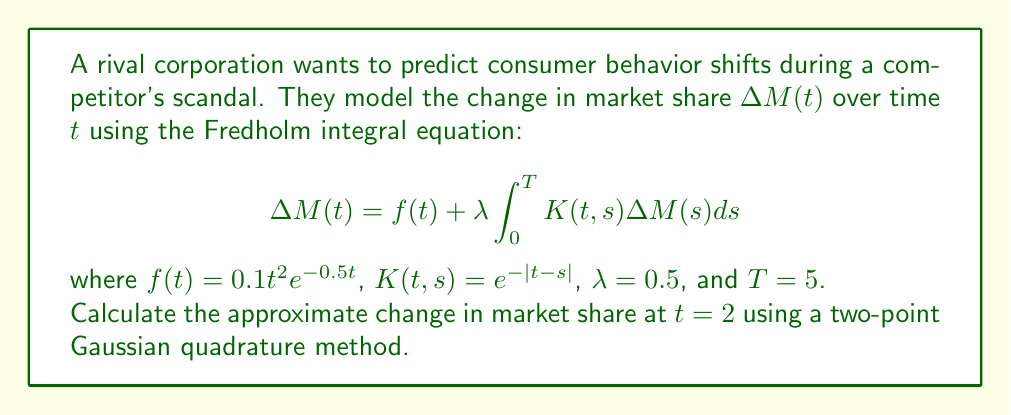Can you answer this question? To solve this problem, we'll follow these steps:

1) First, we need to discretize the integral equation using the Gaussian quadrature method. For a two-point method, we use the formula:

   $$\int_0^T g(x)dx \approx \frac{T}{2}[w_1g(x_1) + w_2g(x_2)]$$

   where $w_1 = w_2 = 1$, and $x_1 = \frac{T}{2}(1-\frac{1}{\sqrt{3}})$, $x_2 = \frac{T}{2}(1+\frac{1}{\sqrt{3}})$

2) Calculate $x_1$ and $x_2$:
   $x_1 = \frac{5}{2}(1-\frac{1}{\sqrt{3}}) \approx 1.0566$
   $x_2 = \frac{5}{2}(1+\frac{1}{\sqrt{3}}) \approx 3.9434$

3) Now, we can write our discretized equation:

   $$\Delta M(t) = f(t) + \lambda \frac{T}{2}[K(t,x_1)\Delta M(x_1) + K(t,x_2)\Delta M(x_2)]$$

4) We need to solve this equation for $t = 2$, $x_1$, and $x_2$. This gives us a system of three equations:

   $$\Delta M(2) = f(2) + \frac{5\lambda}{2}[K(2,x_1)\Delta M(x_1) + K(2,x_2)\Delta M(x_2)]$$
   $$\Delta M(x_1) = f(x_1) + \frac{5\lambda}{2}[K(x_1,x_1)\Delta M(x_1) + K(x_1,x_2)\Delta M(x_2)]$$
   $$\Delta M(x_2) = f(x_2) + \frac{5\lambda}{2}[K(x_2,x_1)\Delta M(x_1) + K(x_2,x_2)\Delta M(x_2)]$$

5) Calculate the values of $f(t)$ and $K(t,s)$:
   $f(2) = 0.1(2)^2e^{-0.5(2)} \approx 0.0811$
   $f(x_1) \approx 0.0304$
   $f(x_2) \approx 0.0399$
   $K(2,x_1) = e^{-|2-1.0566|} \approx 0.3937$
   $K(2,x_2) = e^{-|2-3.9434|} \approx 0.1451$
   $K(x_1,x_1) = 1$
   $K(x_1,x_2) = e^{-|1.0566-3.9434|} \approx 0.0578$
   $K(x_2,x_1) = e^{-|3.9434-1.0566|} \approx 0.0578$
   $K(x_2,x_2) = 1$

6) Substitute these values into our system of equations:

   $$\Delta M(2) = 0.0811 + 1.25[0.3937\Delta M(x_1) + 0.1451\Delta M(x_2)]$$
   $$\Delta M(x_1) = 0.0304 + 1.25[1.0\Delta M(x_1) + 0.0578\Delta M(x_2)]$$
   $$\Delta M(x_2) = 0.0399 + 1.25[0.0578\Delta M(x_1) + 1.0\Delta M(x_2)]$$

7) Solve this system of linear equations. The solution gives:
   $\Delta M(2) \approx 0.1378$
   $\Delta M(x_1) \approx 0.1295$
   $\Delta M(x_2) \approx 0.1669$

Therefore, the approximate change in market share at $t = 2$ is 0.1378 or about 13.78%.
Answer: 0.1378 